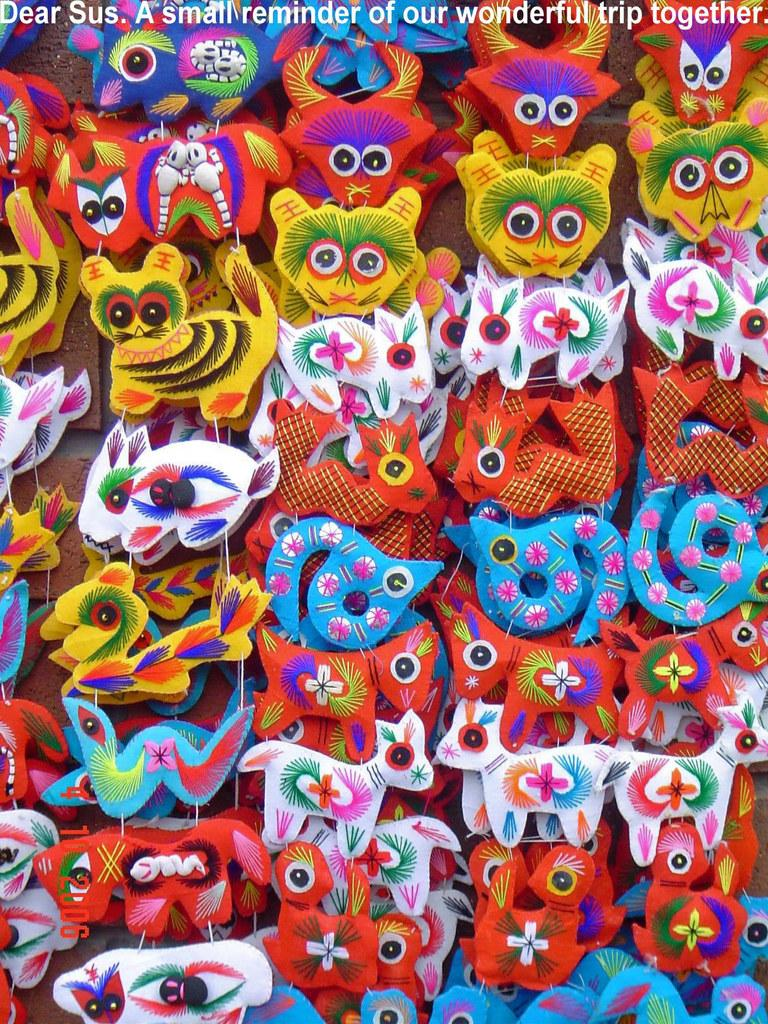What types of objects can be seen in the image? There are decorative items in the image. Is there any text present in the image? Yes, there is text written at the top of the image. What type of hat is being worn by the person in the image? There is no person present in the image, and therefore no hat can be observed. Can you tell me how many books are in the library depicted in the image? There is no library depicted in the image, so it is not possible to determine the number of books. 